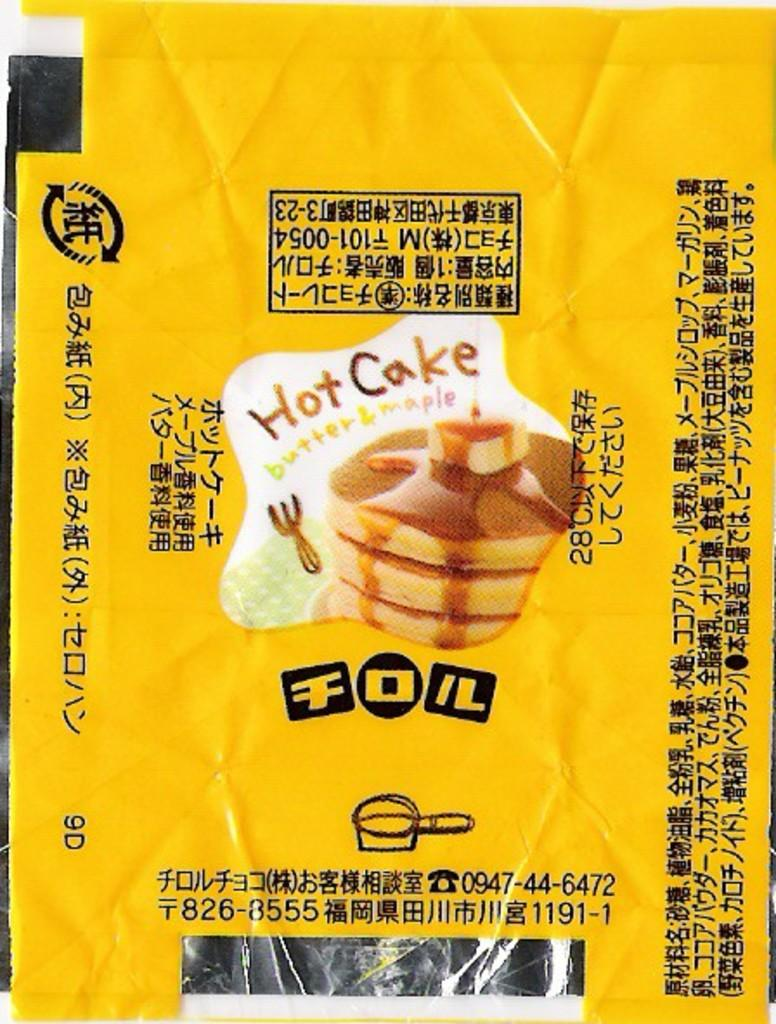<image>
Give a short and clear explanation of the subsequent image. A package of Hot Cake butter and maple mix 